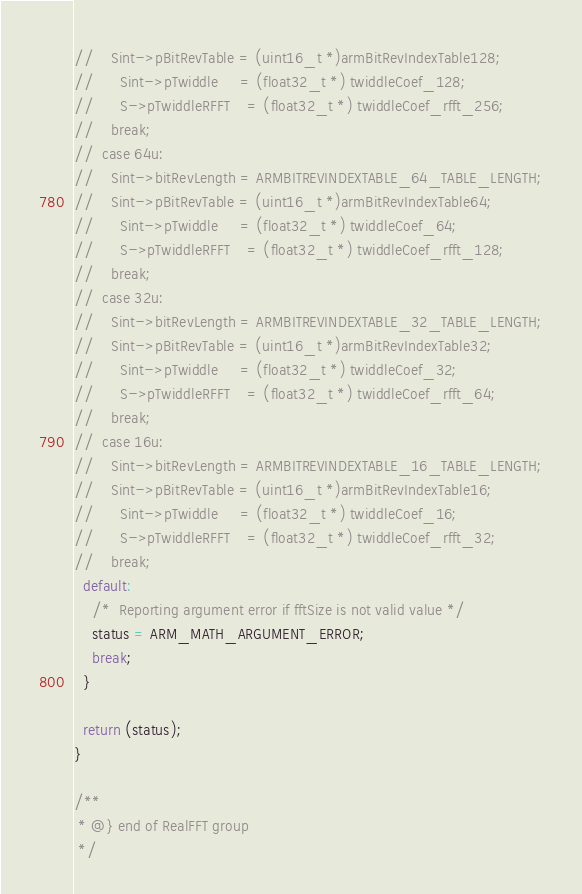Convert code to text. <code><loc_0><loc_0><loc_500><loc_500><_C_>//    Sint->pBitRevTable = (uint16_t *)armBitRevIndexTable128;
//		Sint->pTwiddle     = (float32_t *) twiddleCoef_128;
//		S->pTwiddleRFFT    = (float32_t *) twiddleCoef_rfft_256;
//    break;
//  case 64u:
//    Sint->bitRevLength = ARMBITREVINDEXTABLE_64_TABLE_LENGTH;
//    Sint->pBitRevTable = (uint16_t *)armBitRevIndexTable64;
//		Sint->pTwiddle     = (float32_t *) twiddleCoef_64;
//		S->pTwiddleRFFT    = (float32_t *) twiddleCoef_rfft_128;
//    break;
//  case 32u:
//    Sint->bitRevLength = ARMBITREVINDEXTABLE_32_TABLE_LENGTH;
//    Sint->pBitRevTable = (uint16_t *)armBitRevIndexTable32;
//		Sint->pTwiddle     = (float32_t *) twiddleCoef_32;
//		S->pTwiddleRFFT    = (float32_t *) twiddleCoef_rfft_64;
//    break;
//  case 16u:
//    Sint->bitRevLength = ARMBITREVINDEXTABLE_16_TABLE_LENGTH;
//    Sint->pBitRevTable = (uint16_t *)armBitRevIndexTable16;
//		Sint->pTwiddle     = (float32_t *) twiddleCoef_16;
//		S->pTwiddleRFFT    = (float32_t *) twiddleCoef_rfft_32;
//    break;
  default:
    /*  Reporting argument error if fftSize is not valid value */
    status = ARM_MATH_ARGUMENT_ERROR;
    break;
  }

  return (status);
}

/**
 * @} end of RealFFT group
 */
</code> 